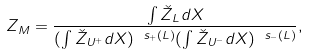Convert formula to latex. <formula><loc_0><loc_0><loc_500><loc_500>Z _ { M } = \frac { \int \check { Z } _ { L } d X } { ( \int \check { Z } _ { U ^ { + } } d X ) ^ { \ s _ { + } ( L ) } ( \int \check { Z } _ { U ^ { - } } d X ) ^ { \ s _ { - } ( L ) } } ,</formula> 